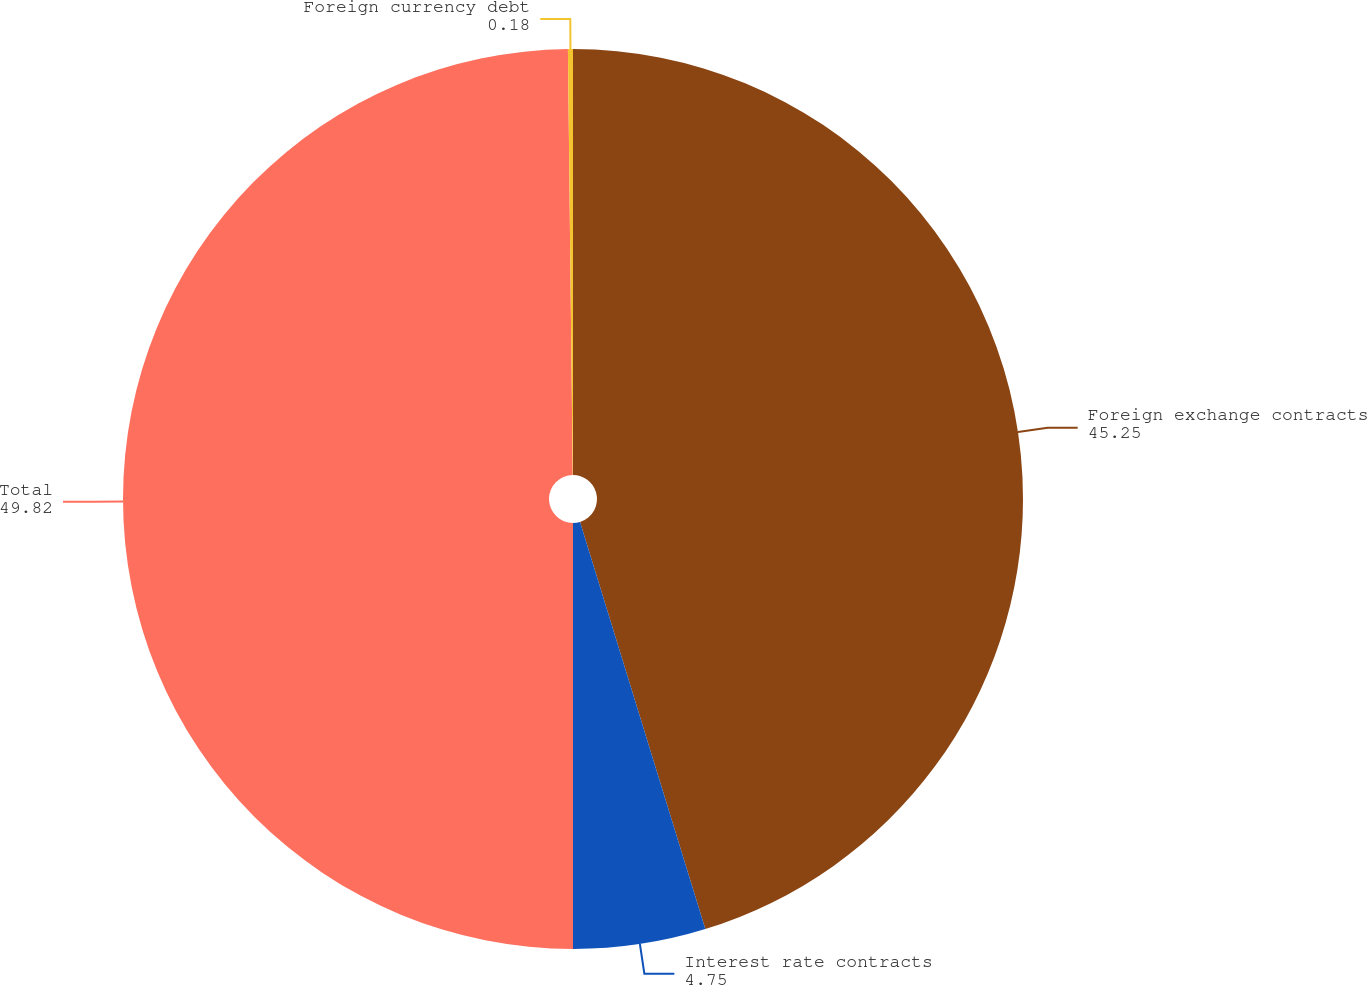Convert chart. <chart><loc_0><loc_0><loc_500><loc_500><pie_chart><fcel>Foreign exchange contracts<fcel>Interest rate contracts<fcel>Total<fcel>Foreign currency debt<nl><fcel>45.25%<fcel>4.75%<fcel>49.82%<fcel>0.18%<nl></chart> 